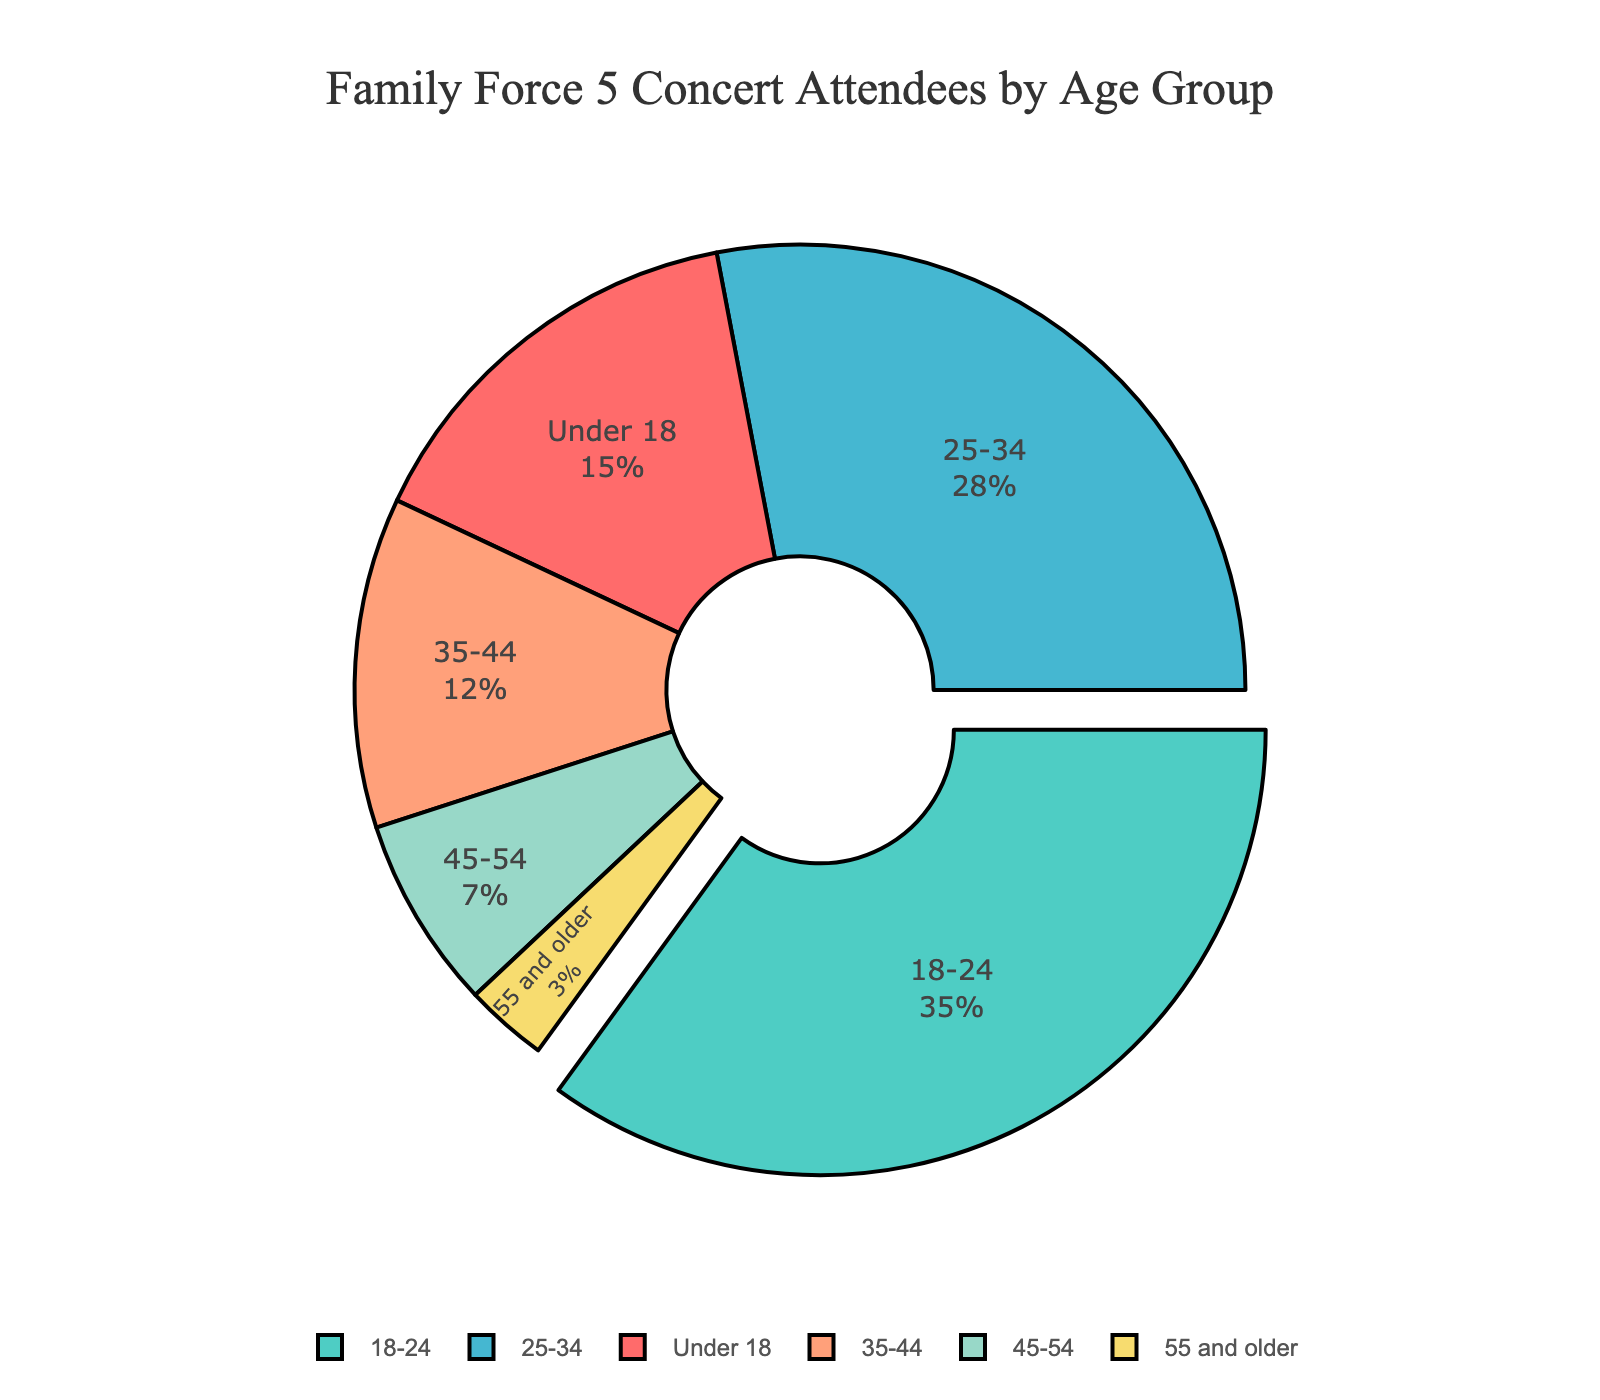Which age group has the largest percentage of concert attendees? The largest segment can be identified by locating the portion of the pie chart that is pulled out from the middle. The 18-24 age group is the one with 35% of the attendees, making it the largest.
Answer: 18-24 What is the combined percentage of concert attendees aged 25-34 and 35-44? First, find the percentages for both groups in the pie chart: 25-34 has 28% and 35-44 has 12%. Adding these together yields 28% + 12% = 40%.
Answer: 40% How does the attendance of people aged under 18 compare to those aged 45-54? The chart shows the percentages of attendees under 18 is 15% and those aged 45-54 is 7%. Comparing these, 15% is greater than 7%.
Answer: Under 18 Which age group contributes the least to concert attendance? By examining the smallest section of the pie chart, the age group 55 and older is the smallest with only 3%.
Answer: 55 and older What is the percentage difference between the 35-44 and 18-24 age groups? The 35-44 group has 12% and the 18-24 group has 35%. The difference is calculated as 35% - 12% = 23%.
Answer: 23% If half of the concert attendees aged 18-24 did not show up, what would be the new percentage for 18-24 attendees assuming the other percentages remain constant? Initially, 18-24 comprises 35% of total attendees. If half of them did not show, their portion of the pie reduces by half, so 35% / 2 = 17.5%. This makes the new percentage 17.5%.
Answer: 17.5% Which age groups together account for more than half of the attendees? By adding the percentages of age groups until the sum is more than 50%: 
- Under 18 = 15%
- 18-24 = 35%
Adding these: 15% + 35% = 50%. This shows the age groups Under 18 and 18-24 together account for exactly half (not more). To exceed half, the next age group should be added:
- 25-34 = 28%
Adding, 15% + 35% + 28% = 78%, which is more than half. Therefore, Under 18, 18-24, and 25-34 together account for more than half of the attendees.
Answer: Under 18, 18-24, 25-34 What is the combined percentage of concert attendees aged 35 and older? Add the percentages for the age groups 35-44, 45-54, and 55 and older: 
- 35-44 = 12%
- 45-54 = 7%
- 55 and older = 3%
Summing up these values, 12% + 7% + 3% = 22%.
Answer: 22% If the 25-34 age group increased by 5%, how would that change the overall distribution? Initially, the 25-34 group is 28%. Increasing this by 5% makes it 28% + 5% = 33%. The new distribution would have:
- Under 18 = 15%
- 18-24 = 35%
- 25-34 = 33%
- 35-44 = 12%
- 45-54 = 7%
- 55 and older = 3%
The sum of the new percentages should still be 100%, so some percentages must be adjusted proportionally, but based on the given data alone, the focus is on the increment in the 25-34 group from 28% to 33%.
Answer: The 25-34 percentage would be 33% How does the attendance percentage of attendees under 18 compare to those aged 35 and older combined? The chart shows attendees under 18 at 15%. Combined attendees for 35 and older (35-44: 12%, 45-54: 7%, 55 and older: 3%) sum up to 22%. Comparing these values, 22% is greater than 15%.
Answer: Aged 35 and older 